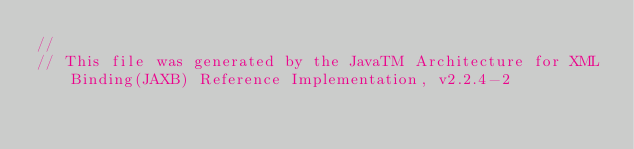Convert code to text. <code><loc_0><loc_0><loc_500><loc_500><_Java_>//
// This file was generated by the JavaTM Architecture for XML Binding(JAXB) Reference Implementation, v2.2.4-2 </code> 